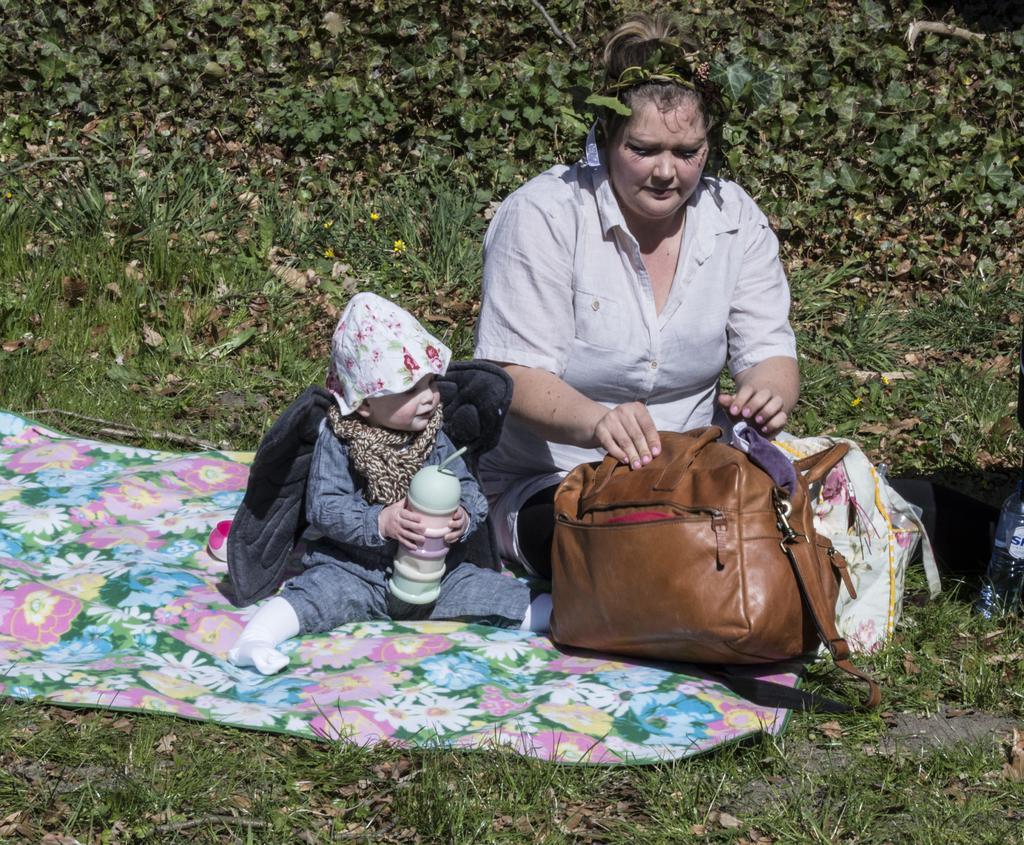Describe this image in one or two sentences. This image consists of two persons. One is child, other one is a woman. They are sitting on the blanket which is placed on grass. Woman is holding a bag which is in brown color. There is a bottle in the right side. 